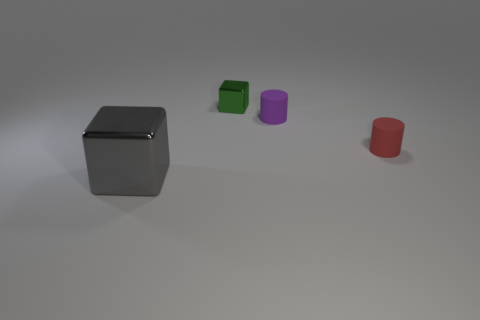What types of geometric shapes are present in this image? The image showcases basic 3D geometric shapes including a cube, a cylinder, and a truncated cone. The large block in the foreground resembles a rectangular prism with beveled edges. 